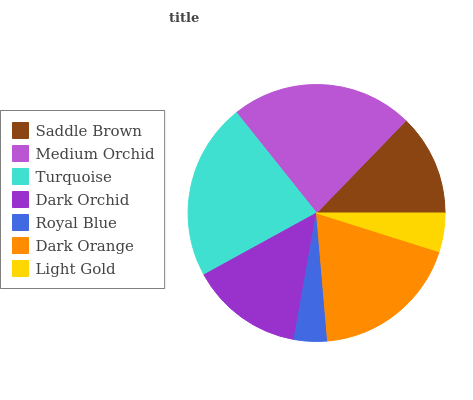Is Royal Blue the minimum?
Answer yes or no. Yes. Is Medium Orchid the maximum?
Answer yes or no. Yes. Is Turquoise the minimum?
Answer yes or no. No. Is Turquoise the maximum?
Answer yes or no. No. Is Medium Orchid greater than Turquoise?
Answer yes or no. Yes. Is Turquoise less than Medium Orchid?
Answer yes or no. Yes. Is Turquoise greater than Medium Orchid?
Answer yes or no. No. Is Medium Orchid less than Turquoise?
Answer yes or no. No. Is Dark Orchid the high median?
Answer yes or no. Yes. Is Dark Orchid the low median?
Answer yes or no. Yes. Is Light Gold the high median?
Answer yes or no. No. Is Royal Blue the low median?
Answer yes or no. No. 